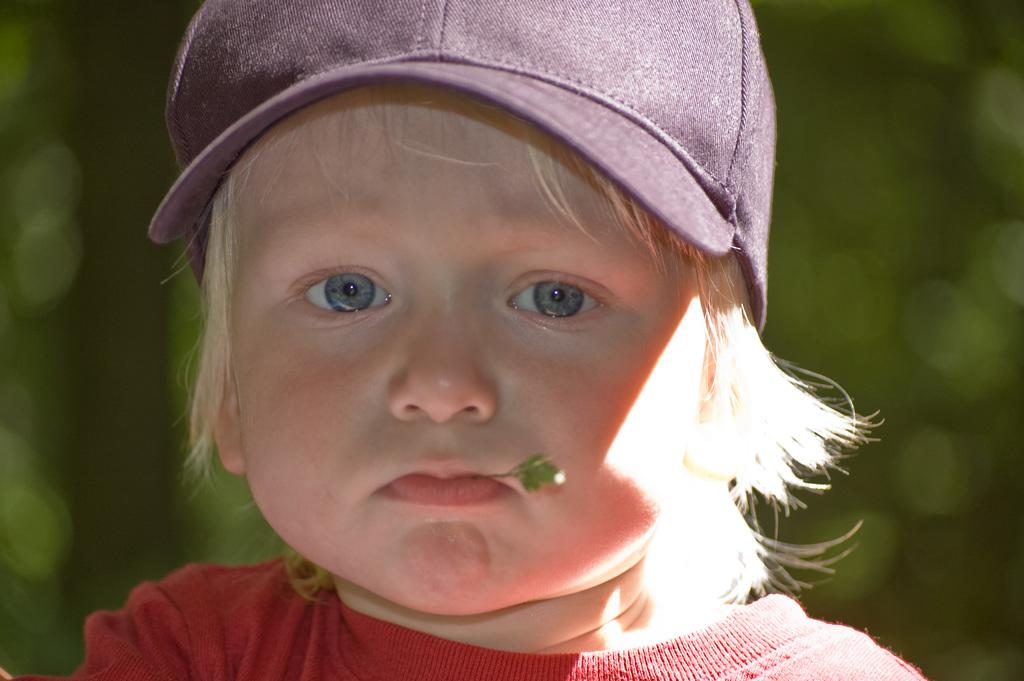What is the main subject of the image? There is a baby in the image. What is the baby wearing on their upper body? The baby is wearing a red t-shirt. What is the baby wearing on their head? The baby is wearing a maroon cap. What can be seen in the background of the image? There are trees in the background of the image. How would you describe the background in the image? The background is blurry. What is the baby doing with the leaf in the image? There is a leaf in the baby's mouth. What type of whip is the baby holding in the image? There is no whip present in the image; the baby has a leaf in their mouth. What caption would you add to the image? The provided facts do not include any information about a caption, so it cannot be determined from the image. 